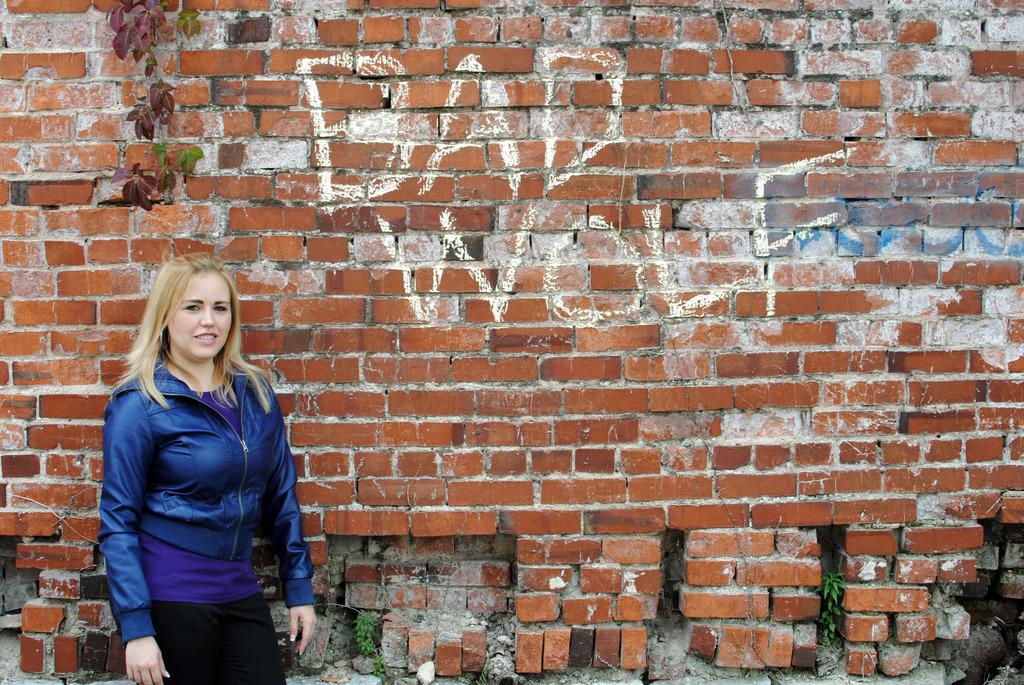What is the main subject of the image? There is a woman standing in the image. What can be seen in the background of the image? There are plants and something written on the wall in the background of the image. What country is the woman visiting in the image? There is no information about the country in the image. How many friends is the woman meeting in the image? There is no information about friends in the image. 